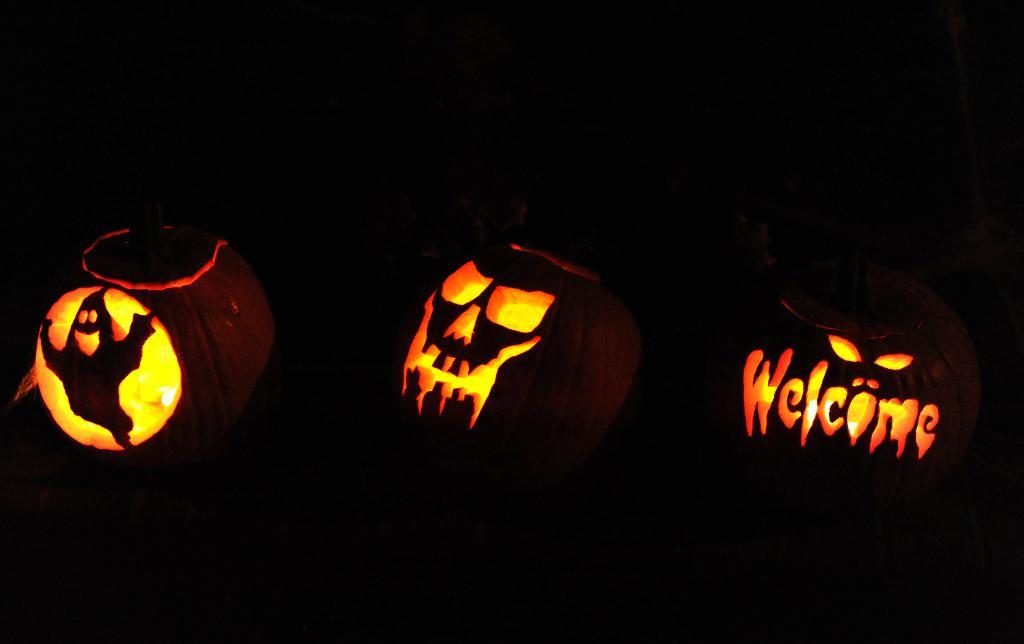What is depicted on the pumpkin in the image? There are carvings on a pumpkin in the image. What holiday or event might the image be related to? The image appears to be related to Halloween. How would you describe the lighting conditions in the image? The image was taken in a dark environment. What type of yam is being stored in the crate in the image? There is no crate or yam present in the image; it features a carved pumpkin in a dark environment. Can you describe the body language of the person in the image? There is no person present in the image, only a carved pumpkin. 